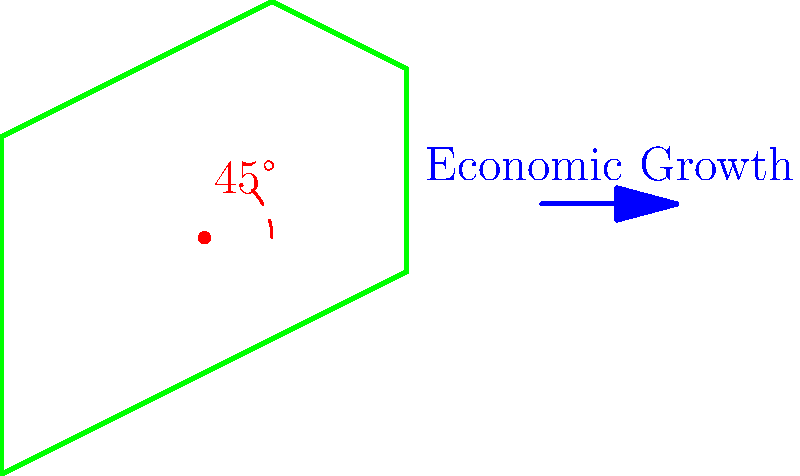The map of Nigeria needs to be rotated 45° clockwise around the point (1.5, 1.75) to align with projected economic growth. If the coordinates of Lagos (a major economic hub) are currently (0, 2.5), what will be its new coordinates after the rotation? To solve this problem, we'll use the rotation formula for transformational geometry:

1) The rotation formula for a point $(x, y)$ around a center $(a, b)$ by an angle $\theta$ clockwise is:
   $x' = (x-a)\cos\theta + (y-b)\sin\theta + a$
   $y' = -(x-a)\sin\theta + (y-b)\cos\theta + b$

2) In our case:
   $(x, y) = (0, 2.5)$ (Lagos coordinates)
   $(a, b) = (1.5, 1.75)$ (rotation center)
   $\theta = 45°$ or $\frac{\pi}{4}$ radians

3) Let's calculate $\cos45°$ and $\sin45°$:
   $\cos45° = \sin45° = \frac{\sqrt{2}}{2}$

4) Now, let's substitute these values into our rotation formulas:
   $x' = (0-1.5)\frac{\sqrt{2}}{2} + (2.5-1.75)\frac{\sqrt{2}}{2} + 1.5$
   $y' = -(0-1.5)\frac{\sqrt{2}}{2} + (2.5-1.75)\frac{\sqrt{2}}{2} + 1.75$

5) Simplify:
   $x' = (-1.5+0.75)\frac{\sqrt{2}}{2} + 1.5 = -0.75\sqrt{2} + 1.5$
   $y' = (1.5+0.75)\frac{\sqrt{2}}{2} + 1.75 = 1.125\sqrt{2} + 1.75$

6) These are the exact values. For an approximate decimal representation:
   $x' \approx 0.44$
   $y' \approx 3.34$
Answer: $(0.44, 3.34)$ (approximate) 